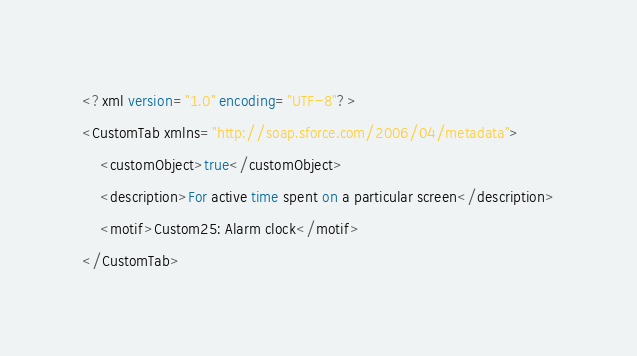Convert code to text. <code><loc_0><loc_0><loc_500><loc_500><_SQL_><?xml version="1.0" encoding="UTF-8"?>
<CustomTab xmlns="http://soap.sforce.com/2006/04/metadata">
    <customObject>true</customObject>
    <description>For active time spent on a particular screen</description>
    <motif>Custom25: Alarm clock</motif>
</CustomTab>
</code> 